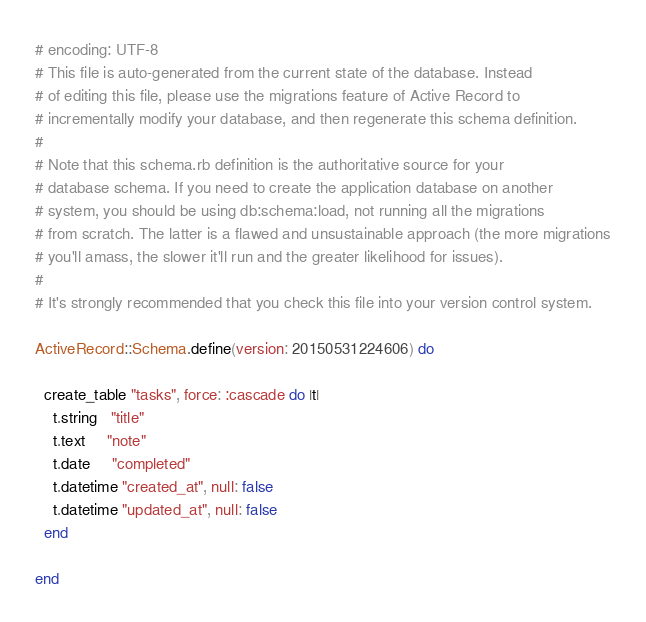<code> <loc_0><loc_0><loc_500><loc_500><_Ruby_># encoding: UTF-8
# This file is auto-generated from the current state of the database. Instead
# of editing this file, please use the migrations feature of Active Record to
# incrementally modify your database, and then regenerate this schema definition.
#
# Note that this schema.rb definition is the authoritative source for your
# database schema. If you need to create the application database on another
# system, you should be using db:schema:load, not running all the migrations
# from scratch. The latter is a flawed and unsustainable approach (the more migrations
# you'll amass, the slower it'll run and the greater likelihood for issues).
#
# It's strongly recommended that you check this file into your version control system.

ActiveRecord::Schema.define(version: 20150531224606) do

  create_table "tasks", force: :cascade do |t|
    t.string   "title"
    t.text     "note"
    t.date     "completed"
    t.datetime "created_at", null: false
    t.datetime "updated_at", null: false
  end

end
</code> 